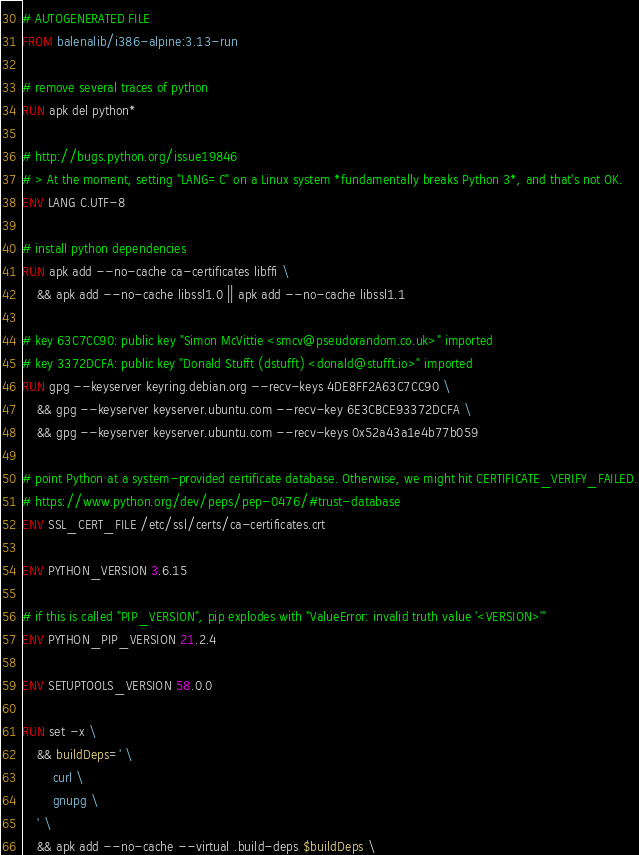Convert code to text. <code><loc_0><loc_0><loc_500><loc_500><_Dockerfile_># AUTOGENERATED FILE
FROM balenalib/i386-alpine:3.13-run

# remove several traces of python
RUN apk del python*

# http://bugs.python.org/issue19846
# > At the moment, setting "LANG=C" on a Linux system *fundamentally breaks Python 3*, and that's not OK.
ENV LANG C.UTF-8

# install python dependencies
RUN apk add --no-cache ca-certificates libffi \
	&& apk add --no-cache libssl1.0 || apk add --no-cache libssl1.1

# key 63C7CC90: public key "Simon McVittie <smcv@pseudorandom.co.uk>" imported
# key 3372DCFA: public key "Donald Stufft (dstufft) <donald@stufft.io>" imported
RUN gpg --keyserver keyring.debian.org --recv-keys 4DE8FF2A63C7CC90 \
	&& gpg --keyserver keyserver.ubuntu.com --recv-key 6E3CBCE93372DCFA \
	&& gpg --keyserver keyserver.ubuntu.com --recv-keys 0x52a43a1e4b77b059

# point Python at a system-provided certificate database. Otherwise, we might hit CERTIFICATE_VERIFY_FAILED.
# https://www.python.org/dev/peps/pep-0476/#trust-database
ENV SSL_CERT_FILE /etc/ssl/certs/ca-certificates.crt

ENV PYTHON_VERSION 3.6.15

# if this is called "PIP_VERSION", pip explodes with "ValueError: invalid truth value '<VERSION>'"
ENV PYTHON_PIP_VERSION 21.2.4

ENV SETUPTOOLS_VERSION 58.0.0

RUN set -x \
	&& buildDeps=' \
		curl \
		gnupg \
	' \
	&& apk add --no-cache --virtual .build-deps $buildDeps \</code> 